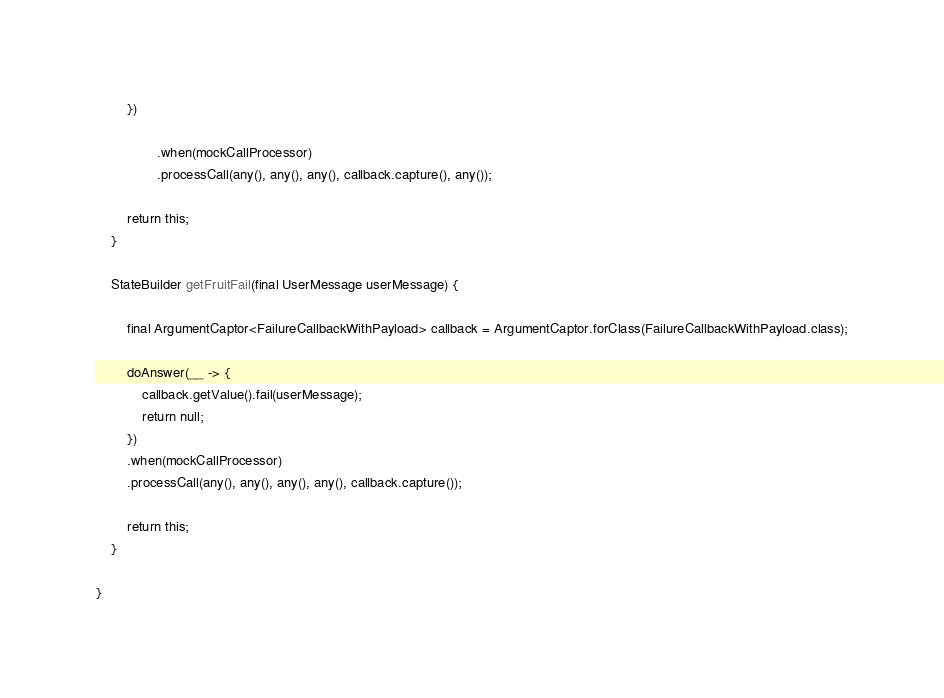<code> <loc_0><loc_0><loc_500><loc_500><_Java_>        })

                .when(mockCallProcessor)
                .processCall(any(), any(), any(), callback.capture(), any());

        return this;
    }

    StateBuilder getFruitFail(final UserMessage userMessage) {

        final ArgumentCaptor<FailureCallbackWithPayload> callback = ArgumentCaptor.forClass(FailureCallbackWithPayload.class);

        doAnswer(__ -> {
            callback.getValue().fail(userMessage);
            return null;
        })
        .when(mockCallProcessor)
        .processCall(any(), any(), any(), any(), callback.capture());

        return this;
    }

}
</code> 